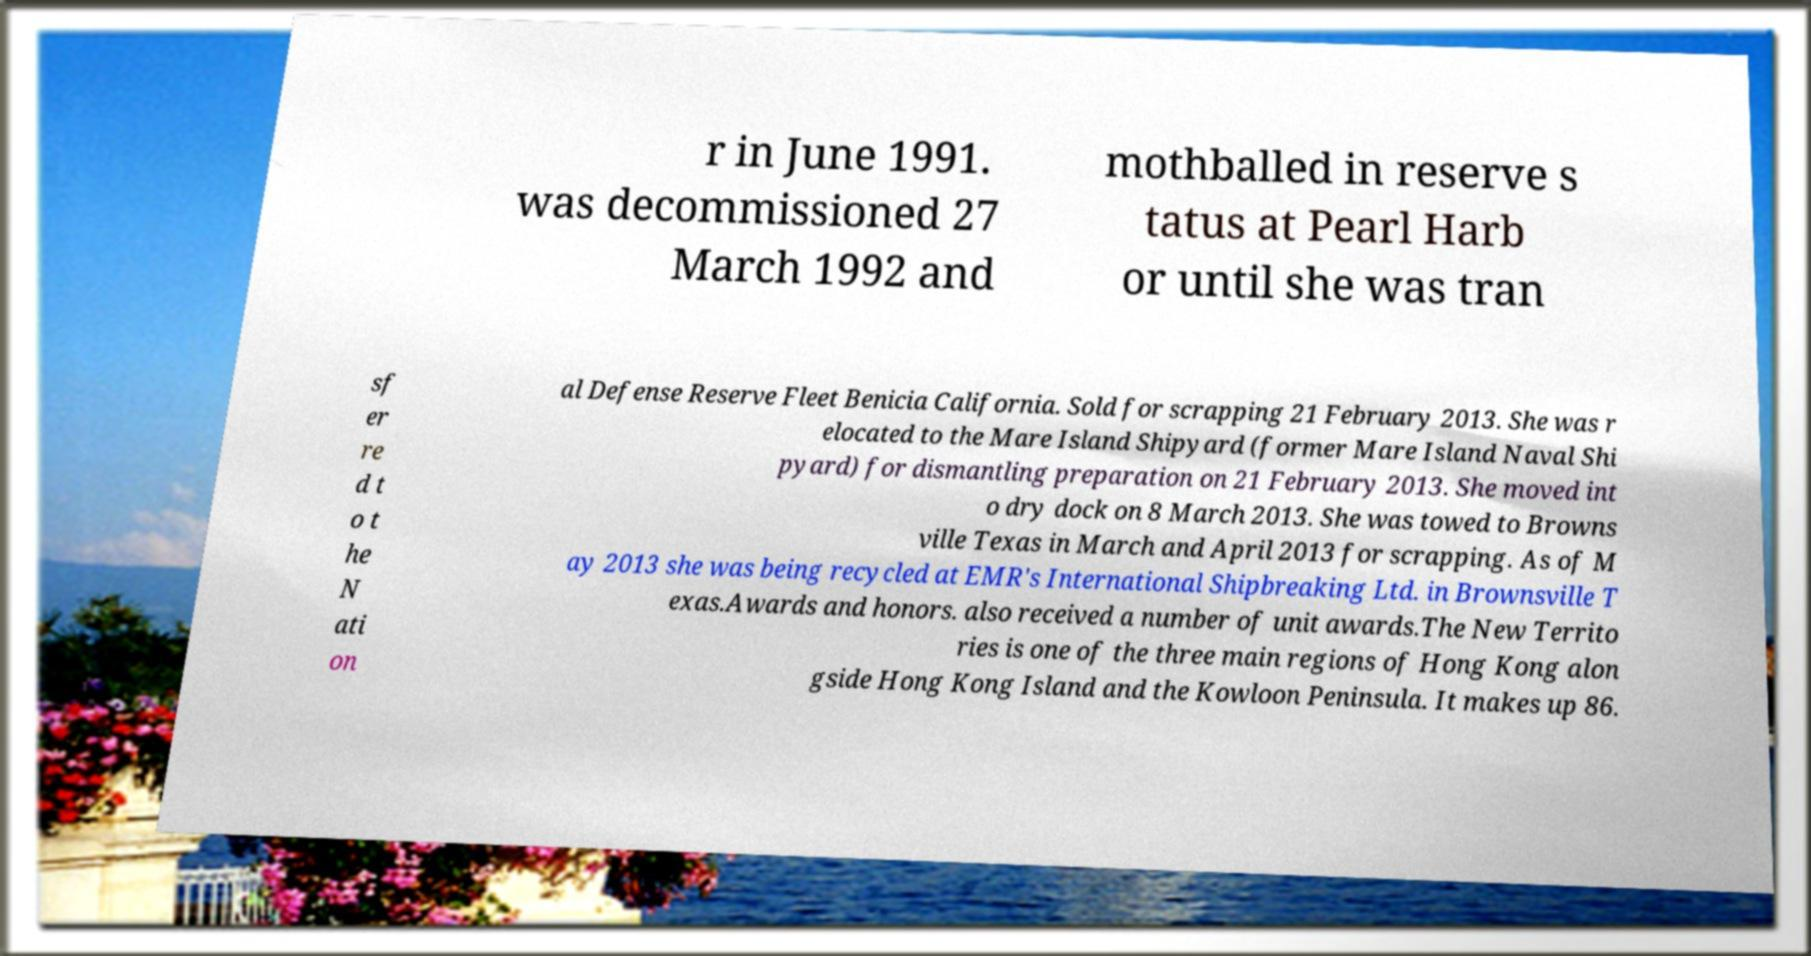There's text embedded in this image that I need extracted. Can you transcribe it verbatim? r in June 1991. was decommissioned 27 March 1992 and mothballed in reserve s tatus at Pearl Harb or until she was tran sf er re d t o t he N ati on al Defense Reserve Fleet Benicia California. Sold for scrapping 21 February 2013. She was r elocated to the Mare Island Shipyard (former Mare Island Naval Shi pyard) for dismantling preparation on 21 February 2013. She moved int o dry dock on 8 March 2013. She was towed to Browns ville Texas in March and April 2013 for scrapping. As of M ay 2013 she was being recycled at EMR's International Shipbreaking Ltd. in Brownsville T exas.Awards and honors. also received a number of unit awards.The New Territo ries is one of the three main regions of Hong Kong alon gside Hong Kong Island and the Kowloon Peninsula. It makes up 86. 